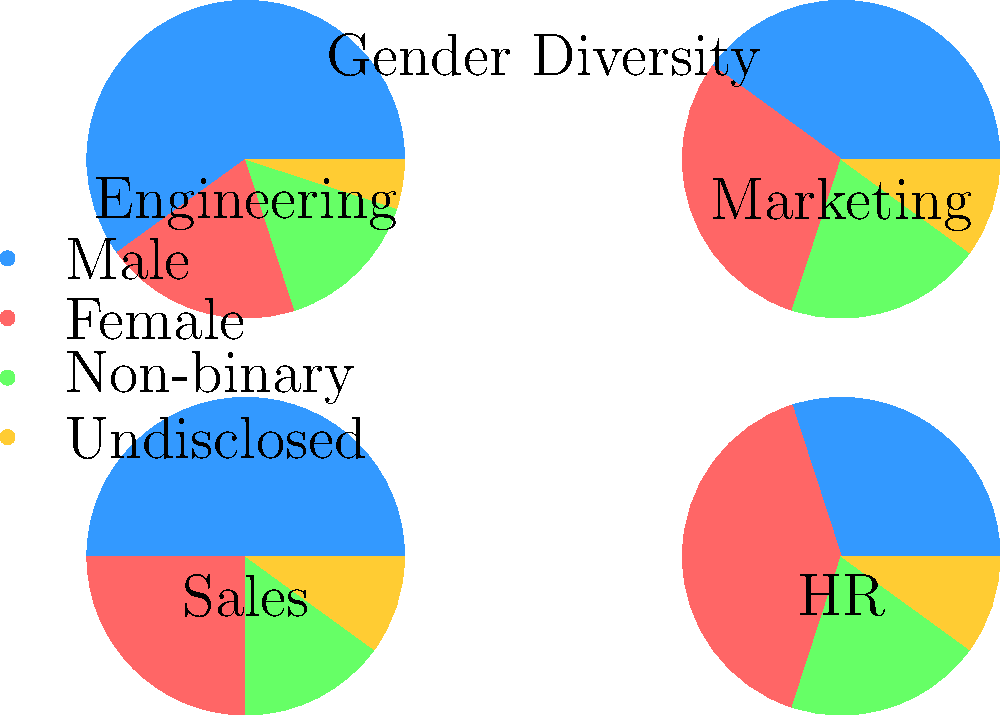Based on the pie charts showing gender diversity across different departments, which department has the highest percentage of female employees? To determine which department has the highest percentage of female employees, we need to compare the second slice (red) of each pie chart, as it represents the female percentage in each department:

1. Engineering: The red slice appears to be about 20% of the pie.
2. Marketing: The red slice is visibly larger, approximately 30% of the pie.
3. Sales: The red slice is about 25% of the pie.
4. HR: The red slice is the largest among all departments, roughly 40% of the pie.

By comparing these percentages, we can conclude that the HR department has the highest percentage of female employees at approximately 40%.
Answer: HR 